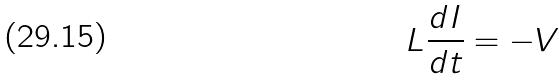<formula> <loc_0><loc_0><loc_500><loc_500>L \frac { d I } { d t } = - V</formula> 